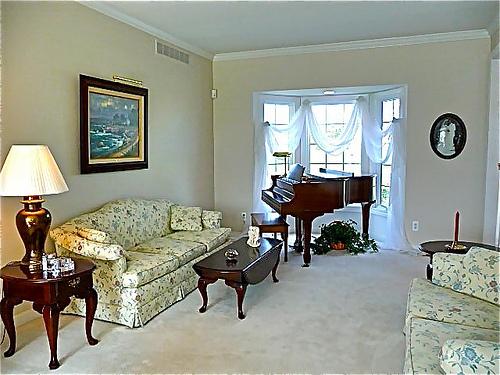What is under the piano?
Quick response, please. Plant. What year was that piano made?
Be succinct. 1990. What kind of portrait hands on the wall?
Short answer required. Picture. Is the lamp on?
Quick response, please. Yes. 